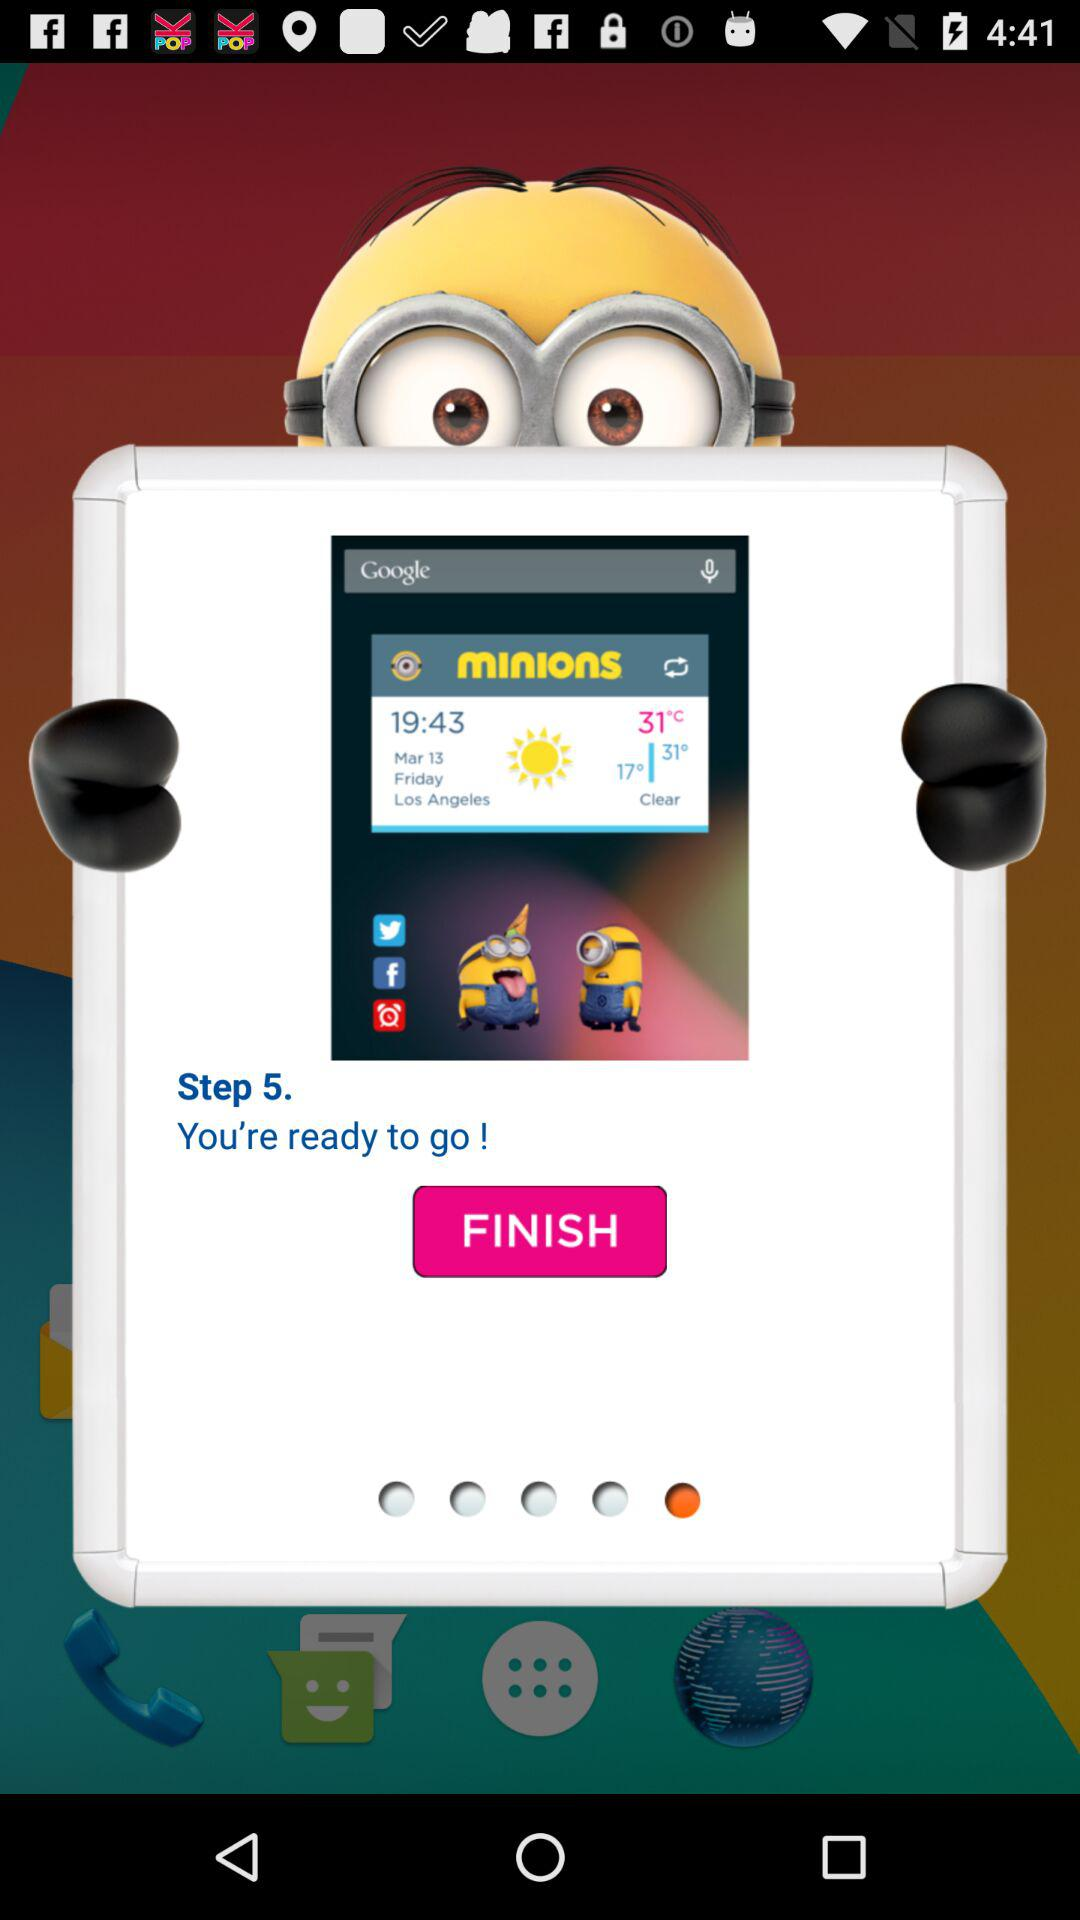On which step number am I? You are on step 5. 